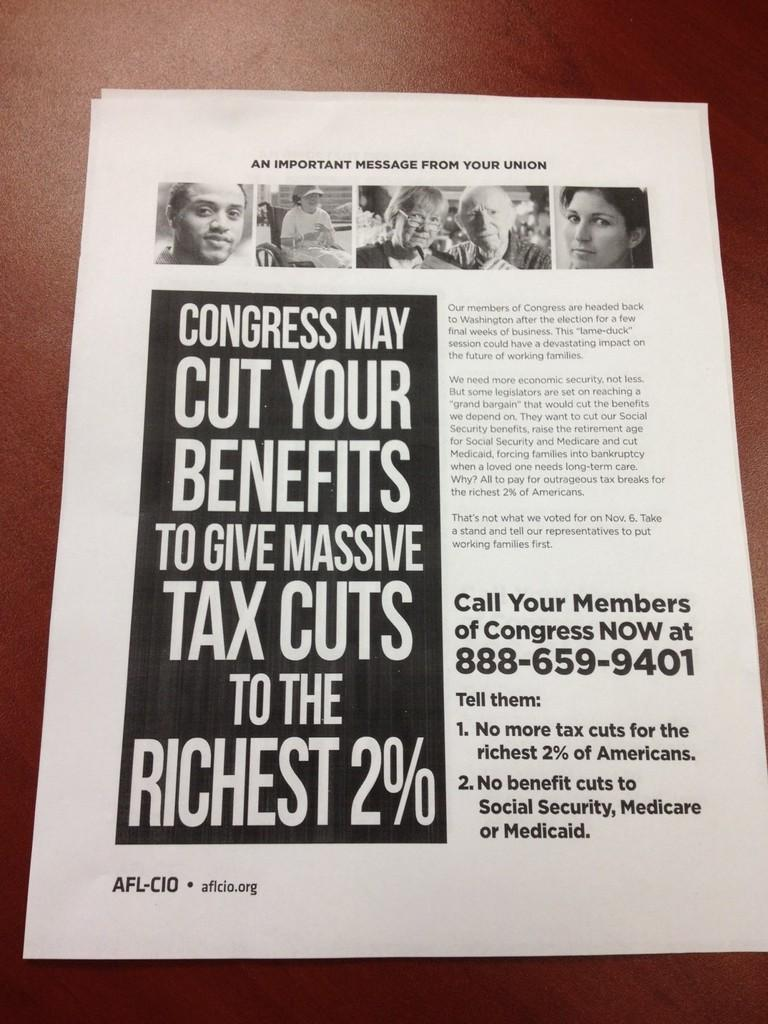<image>
Write a terse but informative summary of the picture. A magazine is opened to a page with "an important message from your union." 